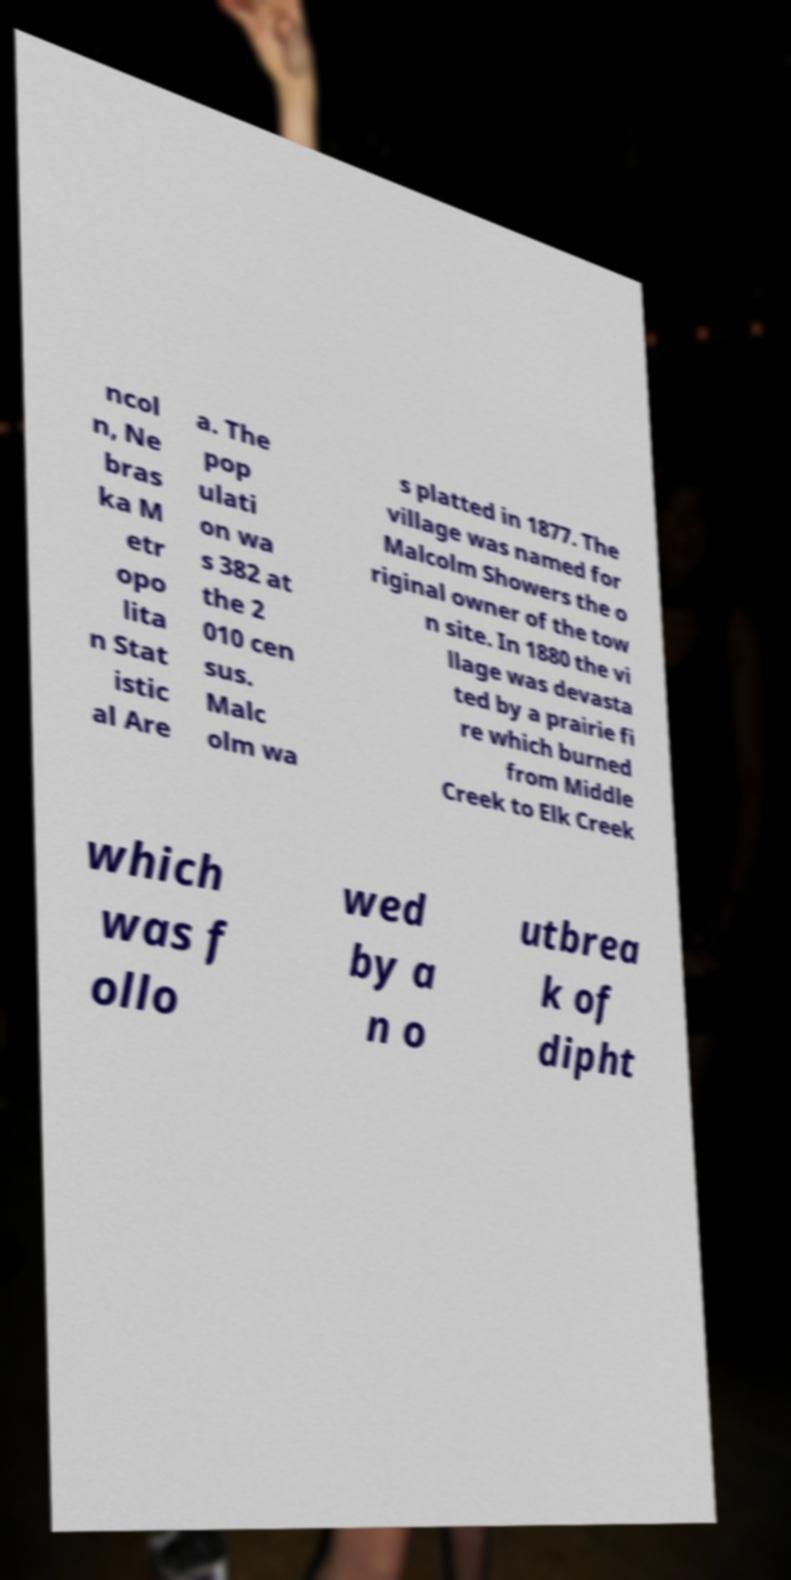Please read and relay the text visible in this image. What does it say? ncol n, Ne bras ka M etr opo lita n Stat istic al Are a. The pop ulati on wa s 382 at the 2 010 cen sus. Malc olm wa s platted in 1877. The village was named for Malcolm Showers the o riginal owner of the tow n site. In 1880 the vi llage was devasta ted by a prairie fi re which burned from Middle Creek to Elk Creek which was f ollo wed by a n o utbrea k of dipht 